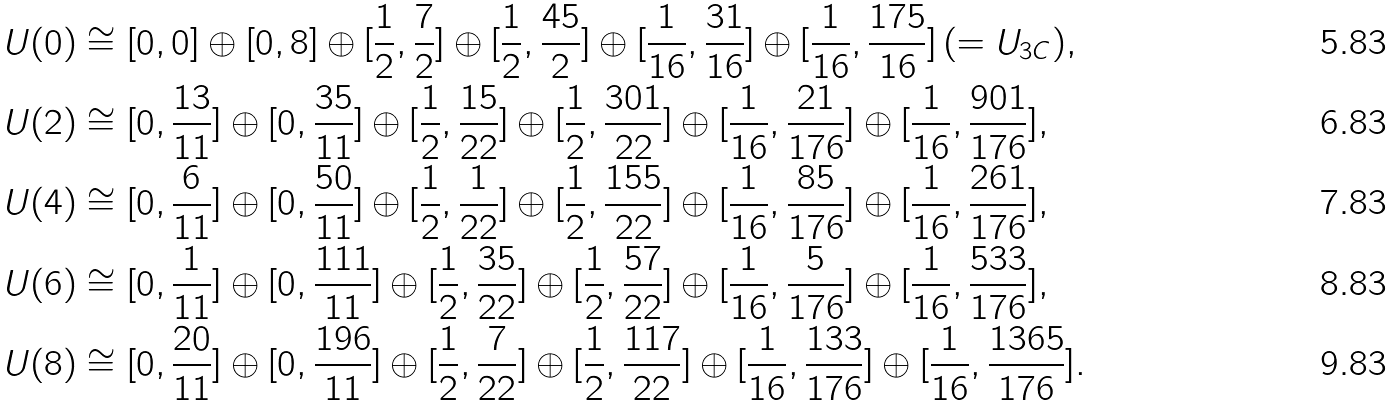<formula> <loc_0><loc_0><loc_500><loc_500>U ( 0 ) & \cong [ 0 , 0 ] \oplus [ 0 , 8 ] \oplus [ \frac { 1 } { 2 } , \frac { 7 } { 2 } ] \oplus [ \frac { 1 } { 2 } , \frac { 4 5 } { 2 } ] \oplus [ \frac { 1 } { 1 6 } , \frac { 3 1 } { 1 6 } ] \oplus [ \frac { 1 } { 1 6 } , \frac { 1 7 5 } { 1 6 } ] \, ( = U _ { 3 C } ) , \\ U ( 2 ) & \cong [ 0 , \frac { 1 3 } { 1 1 } ] \oplus [ 0 , \frac { 3 5 } { 1 1 } ] \oplus [ \frac { 1 } { 2 } , \frac { 1 5 } { 2 2 } ] \oplus [ \frac { 1 } { 2 } , \frac { 3 0 1 } { 2 2 } ] \oplus [ \frac { 1 } { 1 6 } , \frac { 2 1 } { 1 7 6 } ] \oplus [ \frac { 1 } { 1 6 } , \frac { 9 0 1 } { 1 7 6 } ] , \\ U ( 4 ) & \cong [ 0 , \frac { 6 } { 1 1 } ] \oplus [ 0 , \frac { 5 0 } { 1 1 } ] \oplus [ \frac { 1 } { 2 } , \frac { 1 } { 2 2 } ] \oplus [ \frac { 1 } { 2 } , \frac { 1 5 5 } { 2 2 } ] \oplus [ \frac { 1 } { 1 6 } , \frac { 8 5 } { 1 7 6 } ] \oplus [ \frac { 1 } { 1 6 } , \frac { 2 6 1 } { 1 7 6 } ] , \\ U ( 6 ) & \cong [ 0 , \frac { 1 } { 1 1 } ] \oplus [ 0 , \frac { 1 1 1 } { 1 1 } ] \oplus [ \frac { 1 } { 2 } , \frac { 3 5 } { 2 2 } ] \oplus [ \frac { 1 } { 2 } , \frac { 5 7 } { 2 2 } ] \oplus [ \frac { 1 } { 1 6 } , \frac { 5 } { 1 7 6 } ] \oplus [ \frac { 1 } { 1 6 } , \frac { 5 3 3 } { 1 7 6 } ] , \\ U ( 8 ) & \cong [ 0 , \frac { 2 0 } { 1 1 } ] \oplus [ 0 , \frac { 1 9 6 } { 1 1 } ] \oplus [ \frac { 1 } { 2 } , \frac { 7 } { 2 2 } ] \oplus [ \frac { 1 } { 2 } , \frac { 1 1 7 } { 2 2 } ] \oplus [ \frac { 1 } { 1 6 } , \frac { 1 3 3 } { 1 7 6 } ] \oplus [ \frac { 1 } { 1 6 } , \frac { 1 3 6 5 } { 1 7 6 } ] .</formula> 